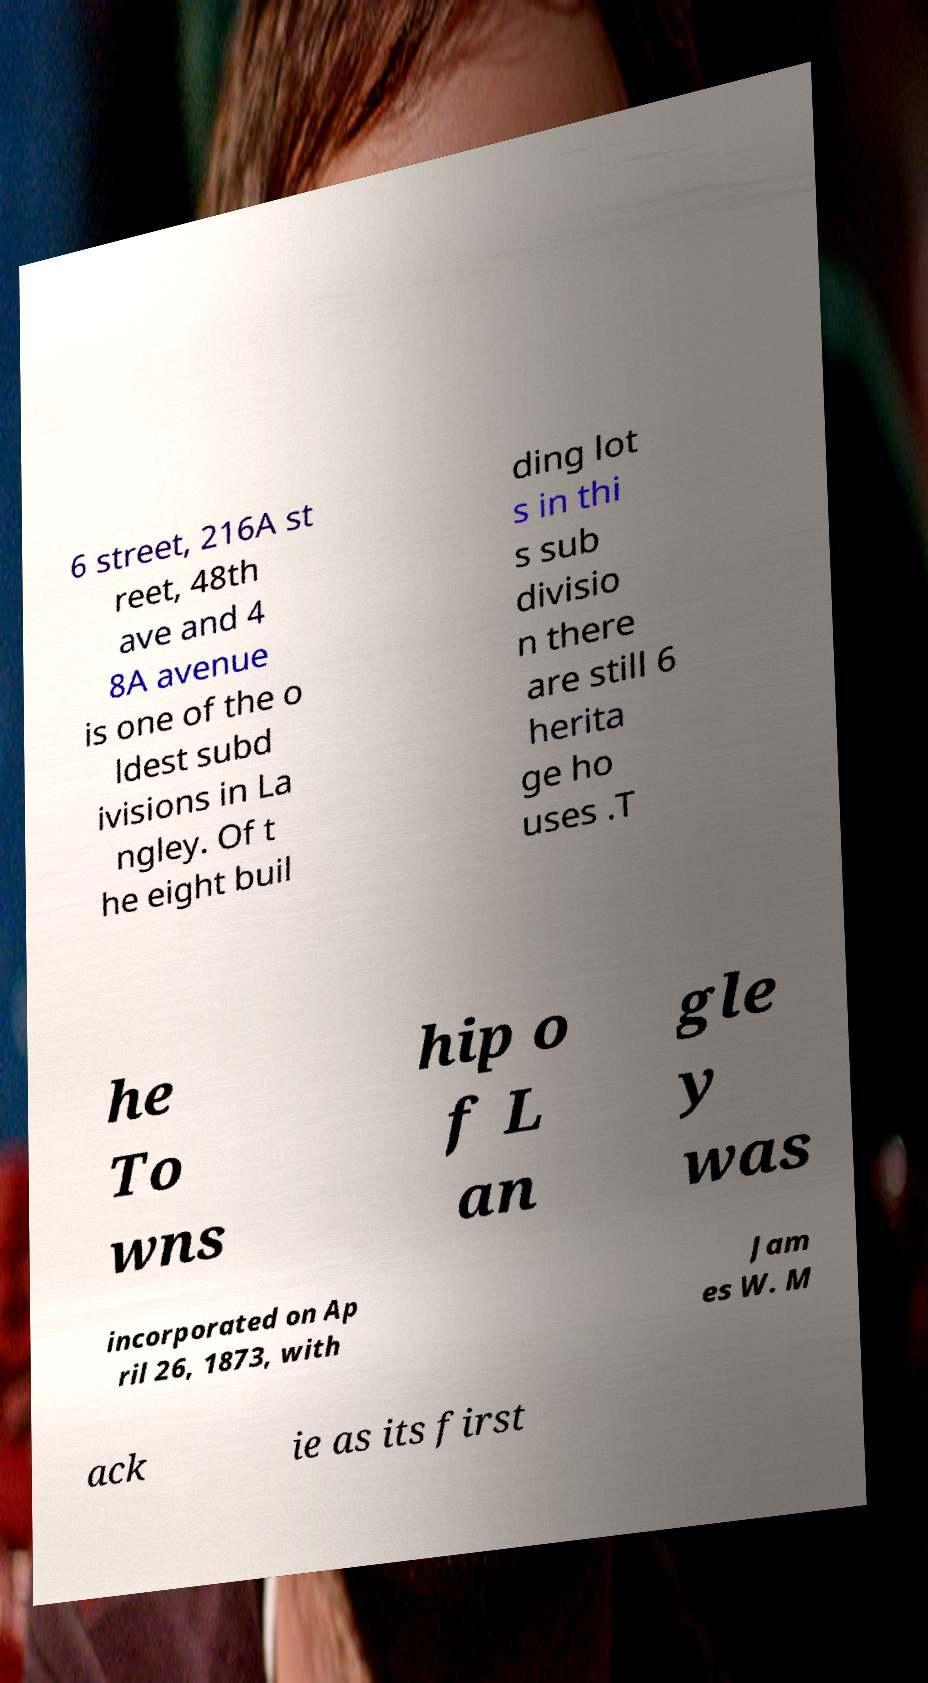Could you assist in decoding the text presented in this image and type it out clearly? 6 street, 216A st reet, 48th ave and 4 8A avenue is one of the o ldest subd ivisions in La ngley. Of t he eight buil ding lot s in thi s sub divisio n there are still 6 herita ge ho uses .T he To wns hip o f L an gle y was incorporated on Ap ril 26, 1873, with Jam es W. M ack ie as its first 